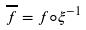Convert formula to latex. <formula><loc_0><loc_0><loc_500><loc_500>\overline { f } = f \circ \xi ^ { - 1 }</formula> 